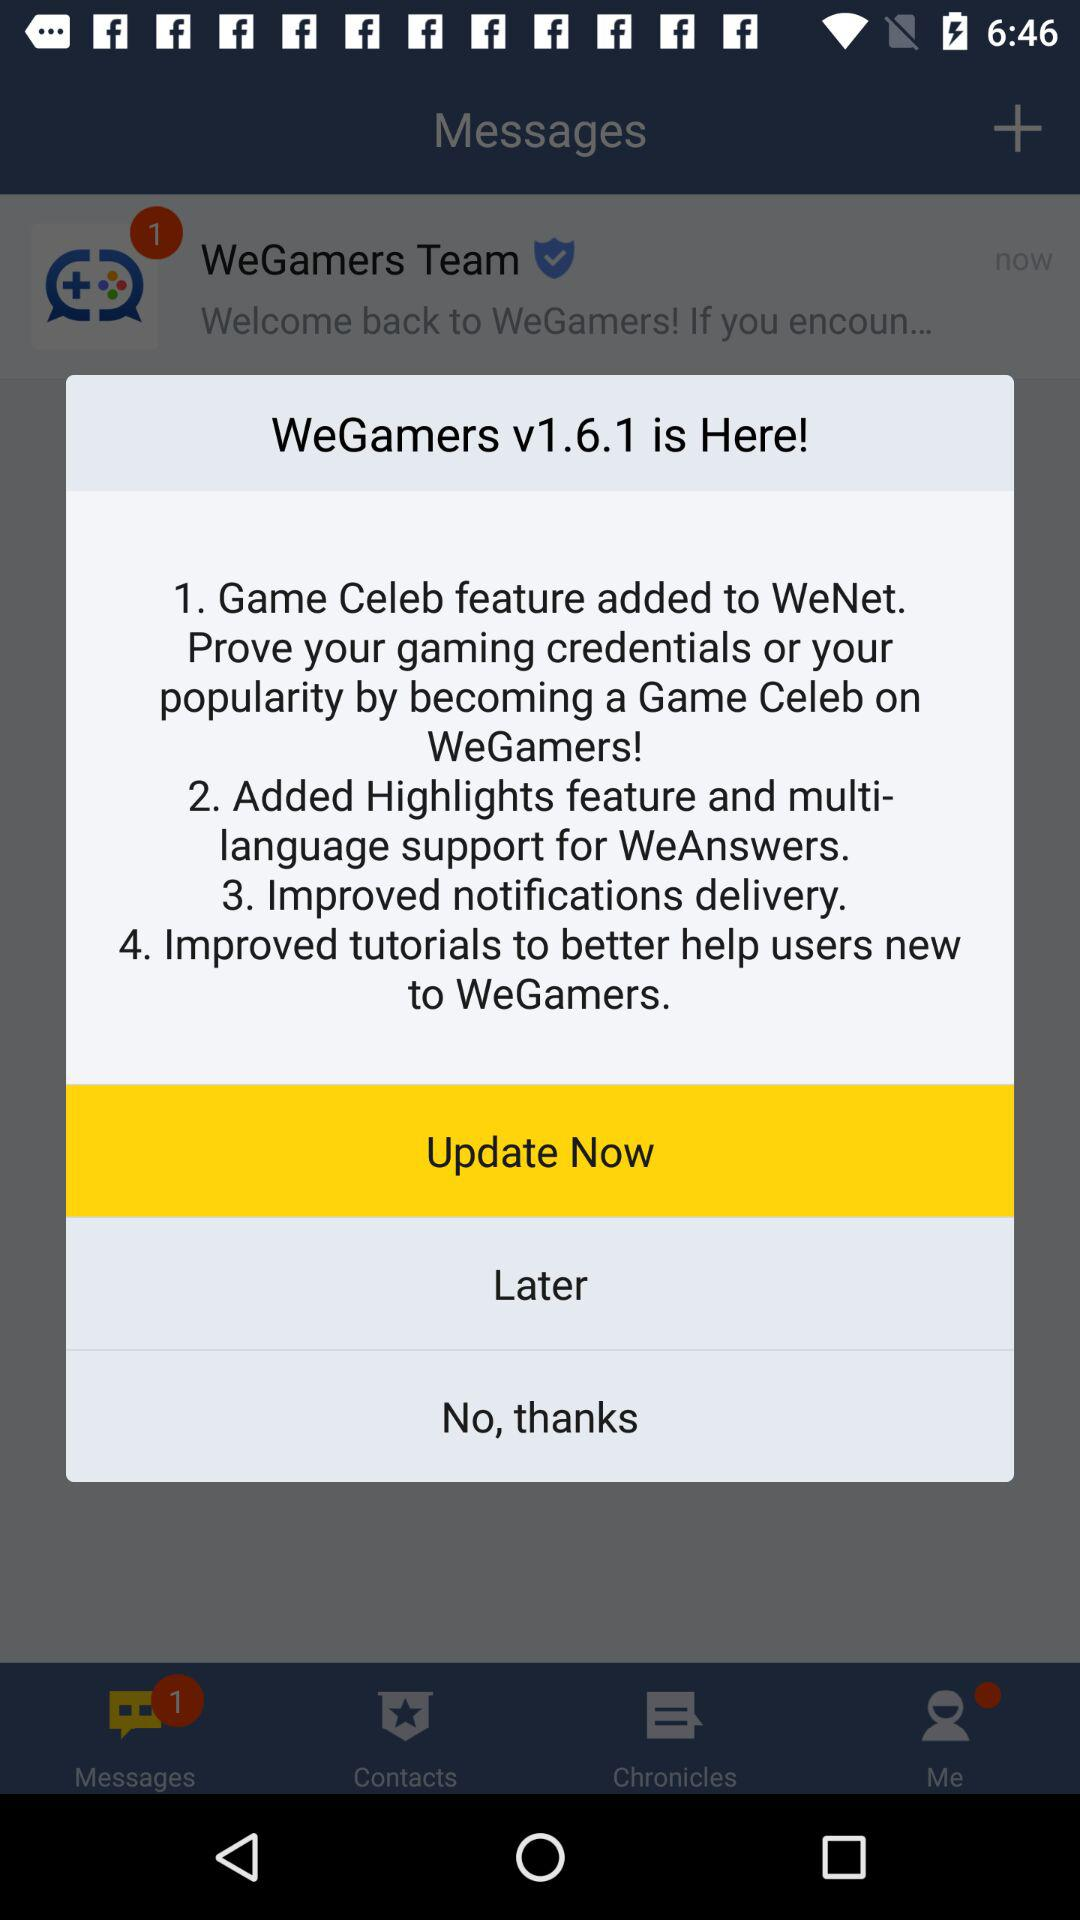What is the application name? The application name is "WeGamers". 